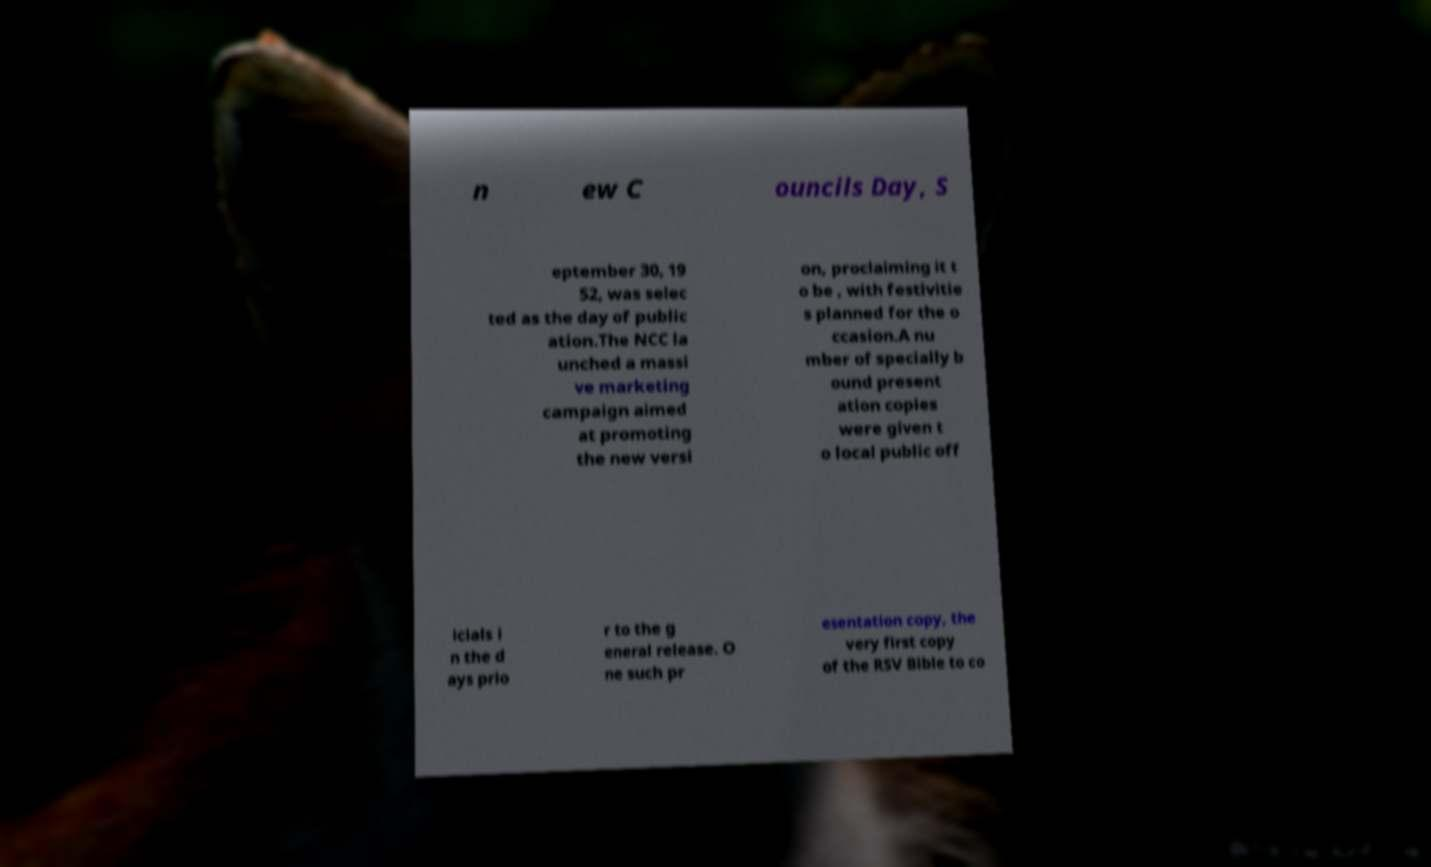Please read and relay the text visible in this image. What does it say? n ew C ouncils Day, S eptember 30, 19 52, was selec ted as the day of public ation.The NCC la unched a massi ve marketing campaign aimed at promoting the new versi on, proclaiming it t o be , with festivitie s planned for the o ccasion.A nu mber of specially b ound present ation copies were given t o local public off icials i n the d ays prio r to the g eneral release. O ne such pr esentation copy, the very first copy of the RSV Bible to co 